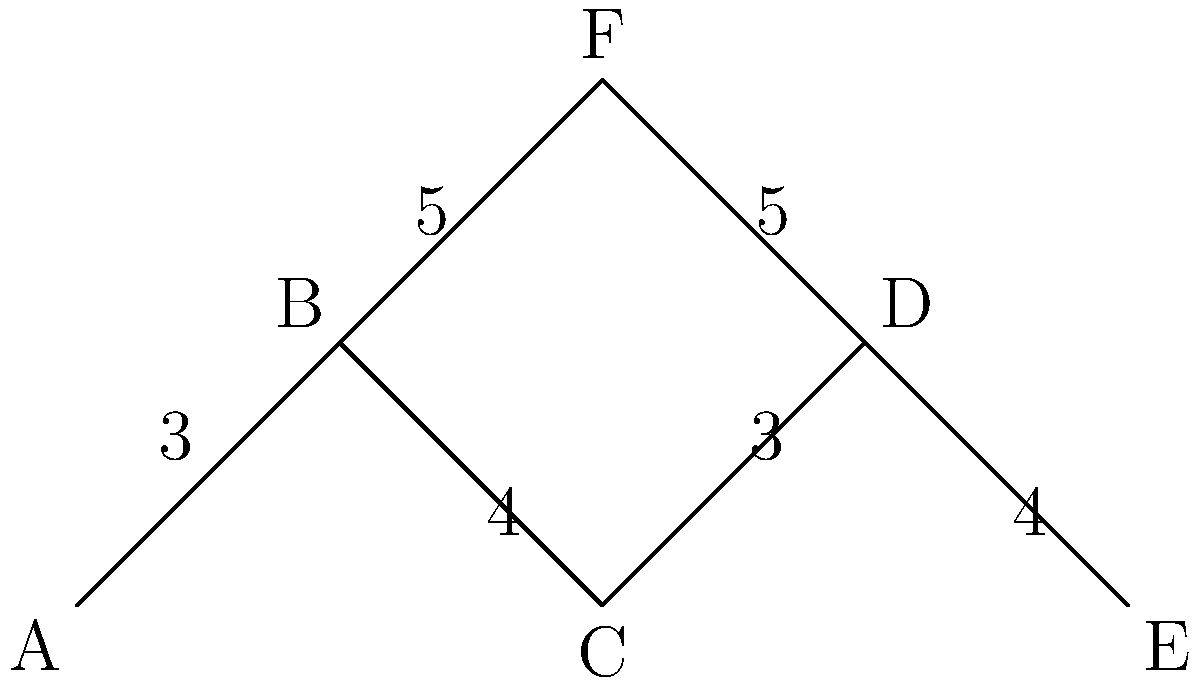As a long-time member of the sports club, you're familiar with the training grounds layout. The diagram above represents different locations on the club's training grounds, with edges representing paths and their corresponding distances in minutes. What is the shortest time (in minutes) it would take for an athlete to run from point A to point E? To find the shortest path from A to E, we need to consider all possible routes and calculate their total distances:

1. Path A-B-C-D-E:
   A to B: 3 minutes
   B to C: 4 minutes
   C to D: 3 minutes
   D to E: 4 minutes
   Total: 3 + 4 + 3 + 4 = 14 minutes

2. Path A-B-F-D-E:
   A to B: 3 minutes
   B to F: 5 minutes
   F to D: 5 minutes
   D to E: 4 minutes
   Total: 3 + 5 + 5 + 4 = 17 minutes

The shortest path is A-B-C-D-E, which takes 14 minutes.
Answer: 14 minutes 